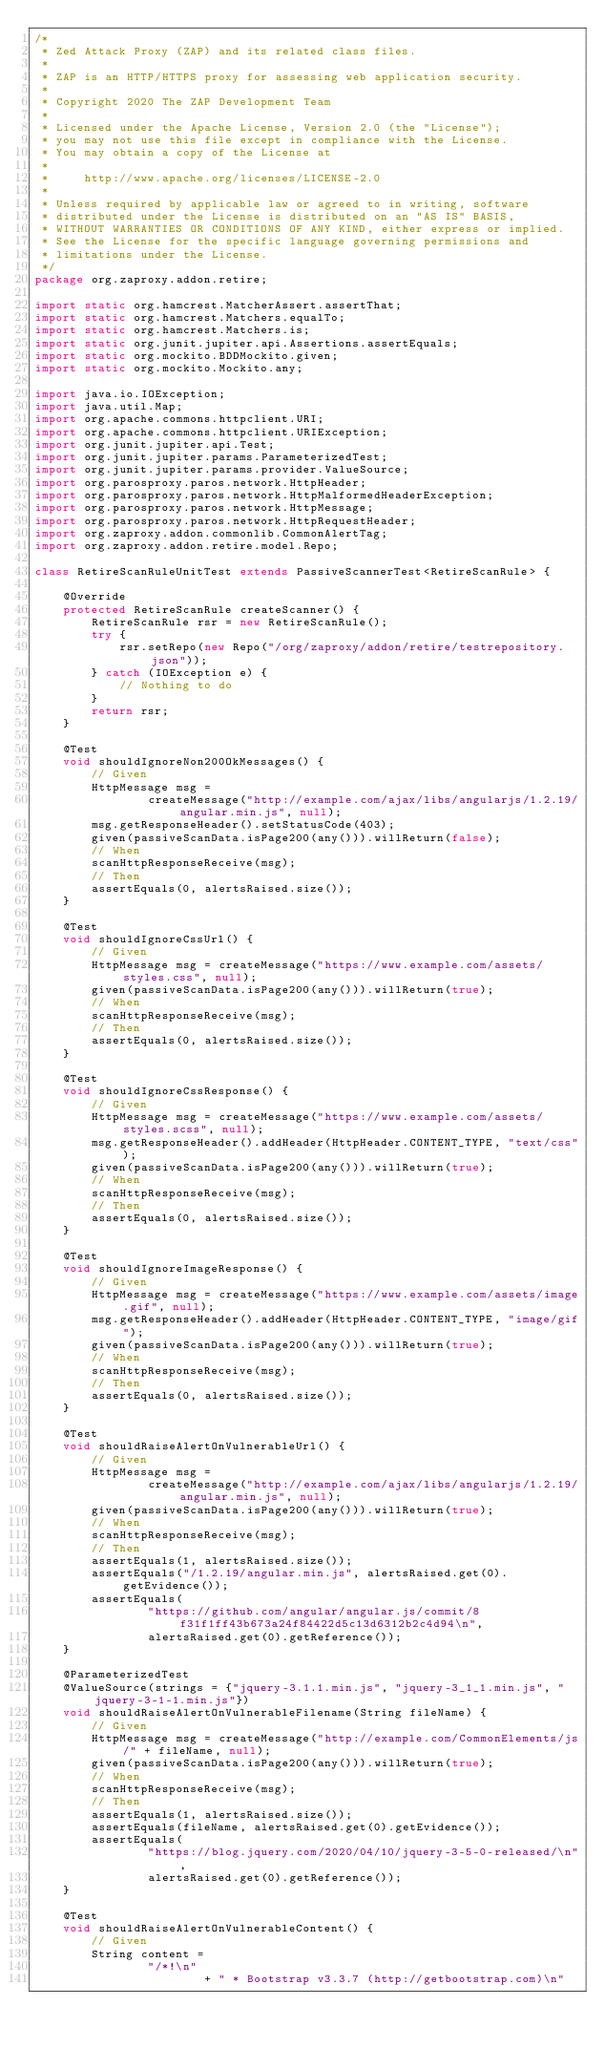Convert code to text. <code><loc_0><loc_0><loc_500><loc_500><_Java_>/*
 * Zed Attack Proxy (ZAP) and its related class files.
 *
 * ZAP is an HTTP/HTTPS proxy for assessing web application security.
 *
 * Copyright 2020 The ZAP Development Team
 *
 * Licensed under the Apache License, Version 2.0 (the "License");
 * you may not use this file except in compliance with the License.
 * You may obtain a copy of the License at
 *
 *     http://www.apache.org/licenses/LICENSE-2.0
 *
 * Unless required by applicable law or agreed to in writing, software
 * distributed under the License is distributed on an "AS IS" BASIS,
 * WITHOUT WARRANTIES OR CONDITIONS OF ANY KIND, either express or implied.
 * See the License for the specific language governing permissions and
 * limitations under the License.
 */
package org.zaproxy.addon.retire;

import static org.hamcrest.MatcherAssert.assertThat;
import static org.hamcrest.Matchers.equalTo;
import static org.hamcrest.Matchers.is;
import static org.junit.jupiter.api.Assertions.assertEquals;
import static org.mockito.BDDMockito.given;
import static org.mockito.Mockito.any;

import java.io.IOException;
import java.util.Map;
import org.apache.commons.httpclient.URI;
import org.apache.commons.httpclient.URIException;
import org.junit.jupiter.api.Test;
import org.junit.jupiter.params.ParameterizedTest;
import org.junit.jupiter.params.provider.ValueSource;
import org.parosproxy.paros.network.HttpHeader;
import org.parosproxy.paros.network.HttpMalformedHeaderException;
import org.parosproxy.paros.network.HttpMessage;
import org.parosproxy.paros.network.HttpRequestHeader;
import org.zaproxy.addon.commonlib.CommonAlertTag;
import org.zaproxy.addon.retire.model.Repo;

class RetireScanRuleUnitTest extends PassiveScannerTest<RetireScanRule> {

    @Override
    protected RetireScanRule createScanner() {
        RetireScanRule rsr = new RetireScanRule();
        try {
            rsr.setRepo(new Repo("/org/zaproxy/addon/retire/testrepository.json"));
        } catch (IOException e) {
            // Nothing to do
        }
        return rsr;
    }

    @Test
    void shouldIgnoreNon200OkMessages() {
        // Given
        HttpMessage msg =
                createMessage("http://example.com/ajax/libs/angularjs/1.2.19/angular.min.js", null);
        msg.getResponseHeader().setStatusCode(403);
        given(passiveScanData.isPage200(any())).willReturn(false);
        // When
        scanHttpResponseReceive(msg);
        // Then
        assertEquals(0, alertsRaised.size());
    }

    @Test
    void shouldIgnoreCssUrl() {
        // Given
        HttpMessage msg = createMessage("https://www.example.com/assets/styles.css", null);
        given(passiveScanData.isPage200(any())).willReturn(true);
        // When
        scanHttpResponseReceive(msg);
        // Then
        assertEquals(0, alertsRaised.size());
    }

    @Test
    void shouldIgnoreCssResponse() {
        // Given
        HttpMessage msg = createMessage("https://www.example.com/assets/styles.scss", null);
        msg.getResponseHeader().addHeader(HttpHeader.CONTENT_TYPE, "text/css");
        given(passiveScanData.isPage200(any())).willReturn(true);
        // When
        scanHttpResponseReceive(msg);
        // Then
        assertEquals(0, alertsRaised.size());
    }

    @Test
    void shouldIgnoreImageResponse() {
        // Given
        HttpMessage msg = createMessage("https://www.example.com/assets/image.gif", null);
        msg.getResponseHeader().addHeader(HttpHeader.CONTENT_TYPE, "image/gif");
        given(passiveScanData.isPage200(any())).willReturn(true);
        // When
        scanHttpResponseReceive(msg);
        // Then
        assertEquals(0, alertsRaised.size());
    }

    @Test
    void shouldRaiseAlertOnVulnerableUrl() {
        // Given
        HttpMessage msg =
                createMessage("http://example.com/ajax/libs/angularjs/1.2.19/angular.min.js", null);
        given(passiveScanData.isPage200(any())).willReturn(true);
        // When
        scanHttpResponseReceive(msg);
        // Then
        assertEquals(1, alertsRaised.size());
        assertEquals("/1.2.19/angular.min.js", alertsRaised.get(0).getEvidence());
        assertEquals(
                "https://github.com/angular/angular.js/commit/8f31f1ff43b673a24f84422d5c13d6312b2c4d94\n",
                alertsRaised.get(0).getReference());
    }

    @ParameterizedTest
    @ValueSource(strings = {"jquery-3.1.1.min.js", "jquery-3_1_1.min.js", "jquery-3-1-1.min.js"})
    void shouldRaiseAlertOnVulnerableFilename(String fileName) {
        // Given
        HttpMessage msg = createMessage("http://example.com/CommonElements/js/" + fileName, null);
        given(passiveScanData.isPage200(any())).willReturn(true);
        // When
        scanHttpResponseReceive(msg);
        // Then
        assertEquals(1, alertsRaised.size());
        assertEquals(fileName, alertsRaised.get(0).getEvidence());
        assertEquals(
                "https://blog.jquery.com/2020/04/10/jquery-3-5-0-released/\n",
                alertsRaised.get(0).getReference());
    }

    @Test
    void shouldRaiseAlertOnVulnerableContent() {
        // Given
        String content =
                "/*!\n"
                        + " * Bootstrap v3.3.7 (http://getbootstrap.com)\n"</code> 